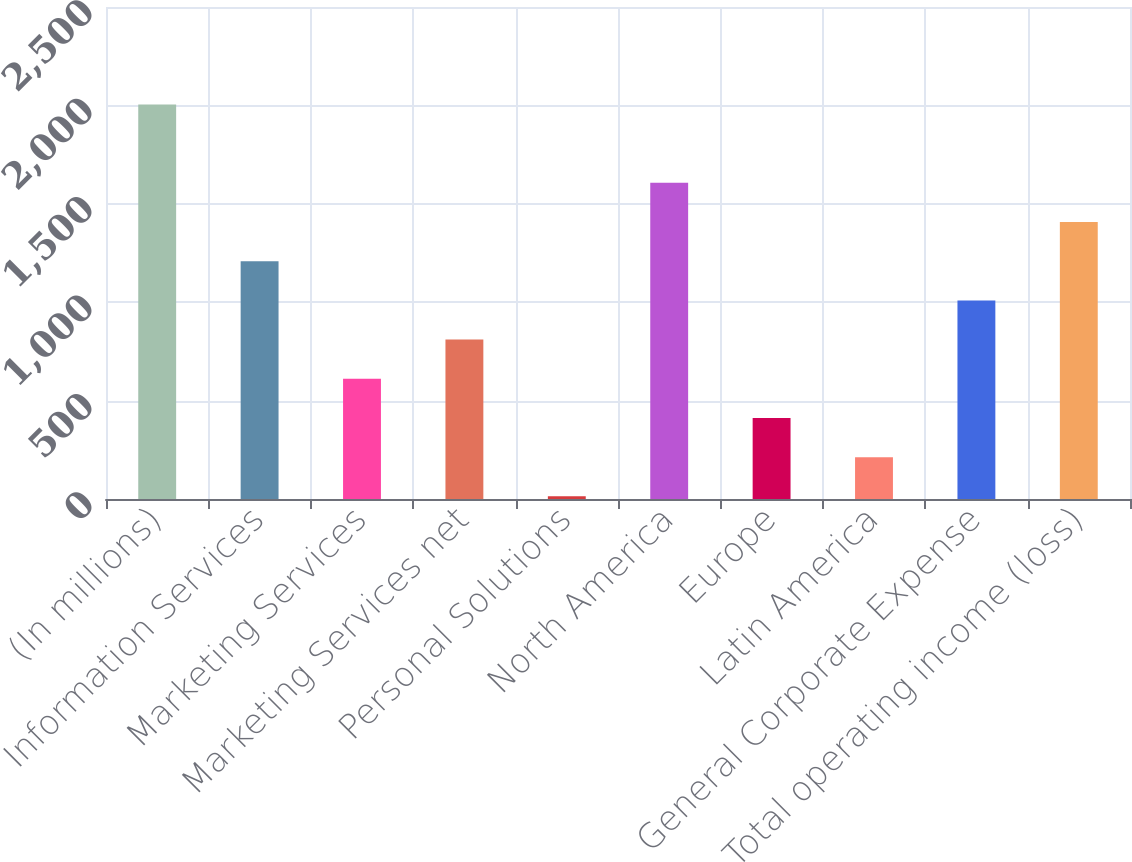Convert chart. <chart><loc_0><loc_0><loc_500><loc_500><bar_chart><fcel>(In millions)<fcel>Information Services<fcel>Marketing Services<fcel>Marketing Services net<fcel>Personal Solutions<fcel>North America<fcel>Europe<fcel>Latin America<fcel>General Corporate Expense<fcel>Total operating income (loss)<nl><fcel>2005<fcel>1208.4<fcel>610.95<fcel>810.1<fcel>13.5<fcel>1606.7<fcel>411.8<fcel>212.65<fcel>1009.25<fcel>1407.55<nl></chart> 